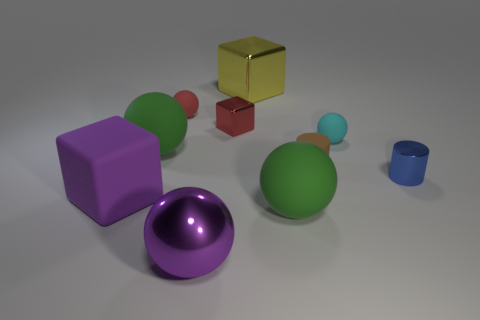Is the number of metal cubes on the left side of the cyan thing the same as the number of tiny rubber spheres?
Your answer should be compact. Yes. Do the green sphere on the right side of the purple metallic sphere and the big yellow thing have the same size?
Provide a short and direct response. Yes. What number of cubes are there?
Keep it short and to the point. 3. How many things are behind the red shiny object and to the left of the purple shiny object?
Give a very brief answer. 1. Is there a large purple cylinder made of the same material as the big yellow thing?
Provide a short and direct response. No. The tiny object that is to the left of the large metallic object in front of the red metallic cube is made of what material?
Your answer should be compact. Rubber. Are there the same number of blue metallic objects behind the small blue thing and small things that are on the right side of the large yellow shiny block?
Your answer should be very brief. No. Does the small brown object have the same shape as the blue object?
Ensure brevity in your answer.  Yes. What material is the thing that is right of the small metal block and behind the small cyan rubber object?
Give a very brief answer. Metal. What number of purple objects are the same shape as the yellow metallic thing?
Keep it short and to the point. 1. 